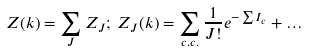Convert formula to latex. <formula><loc_0><loc_0><loc_500><loc_500>Z ( k ) = \sum _ { J } Z _ { J } ; \, Z _ { J } ( k ) = \sum _ { c . c . } \frac { 1 } { J ! } e ^ { - \sum I _ { c } } + \dots</formula> 